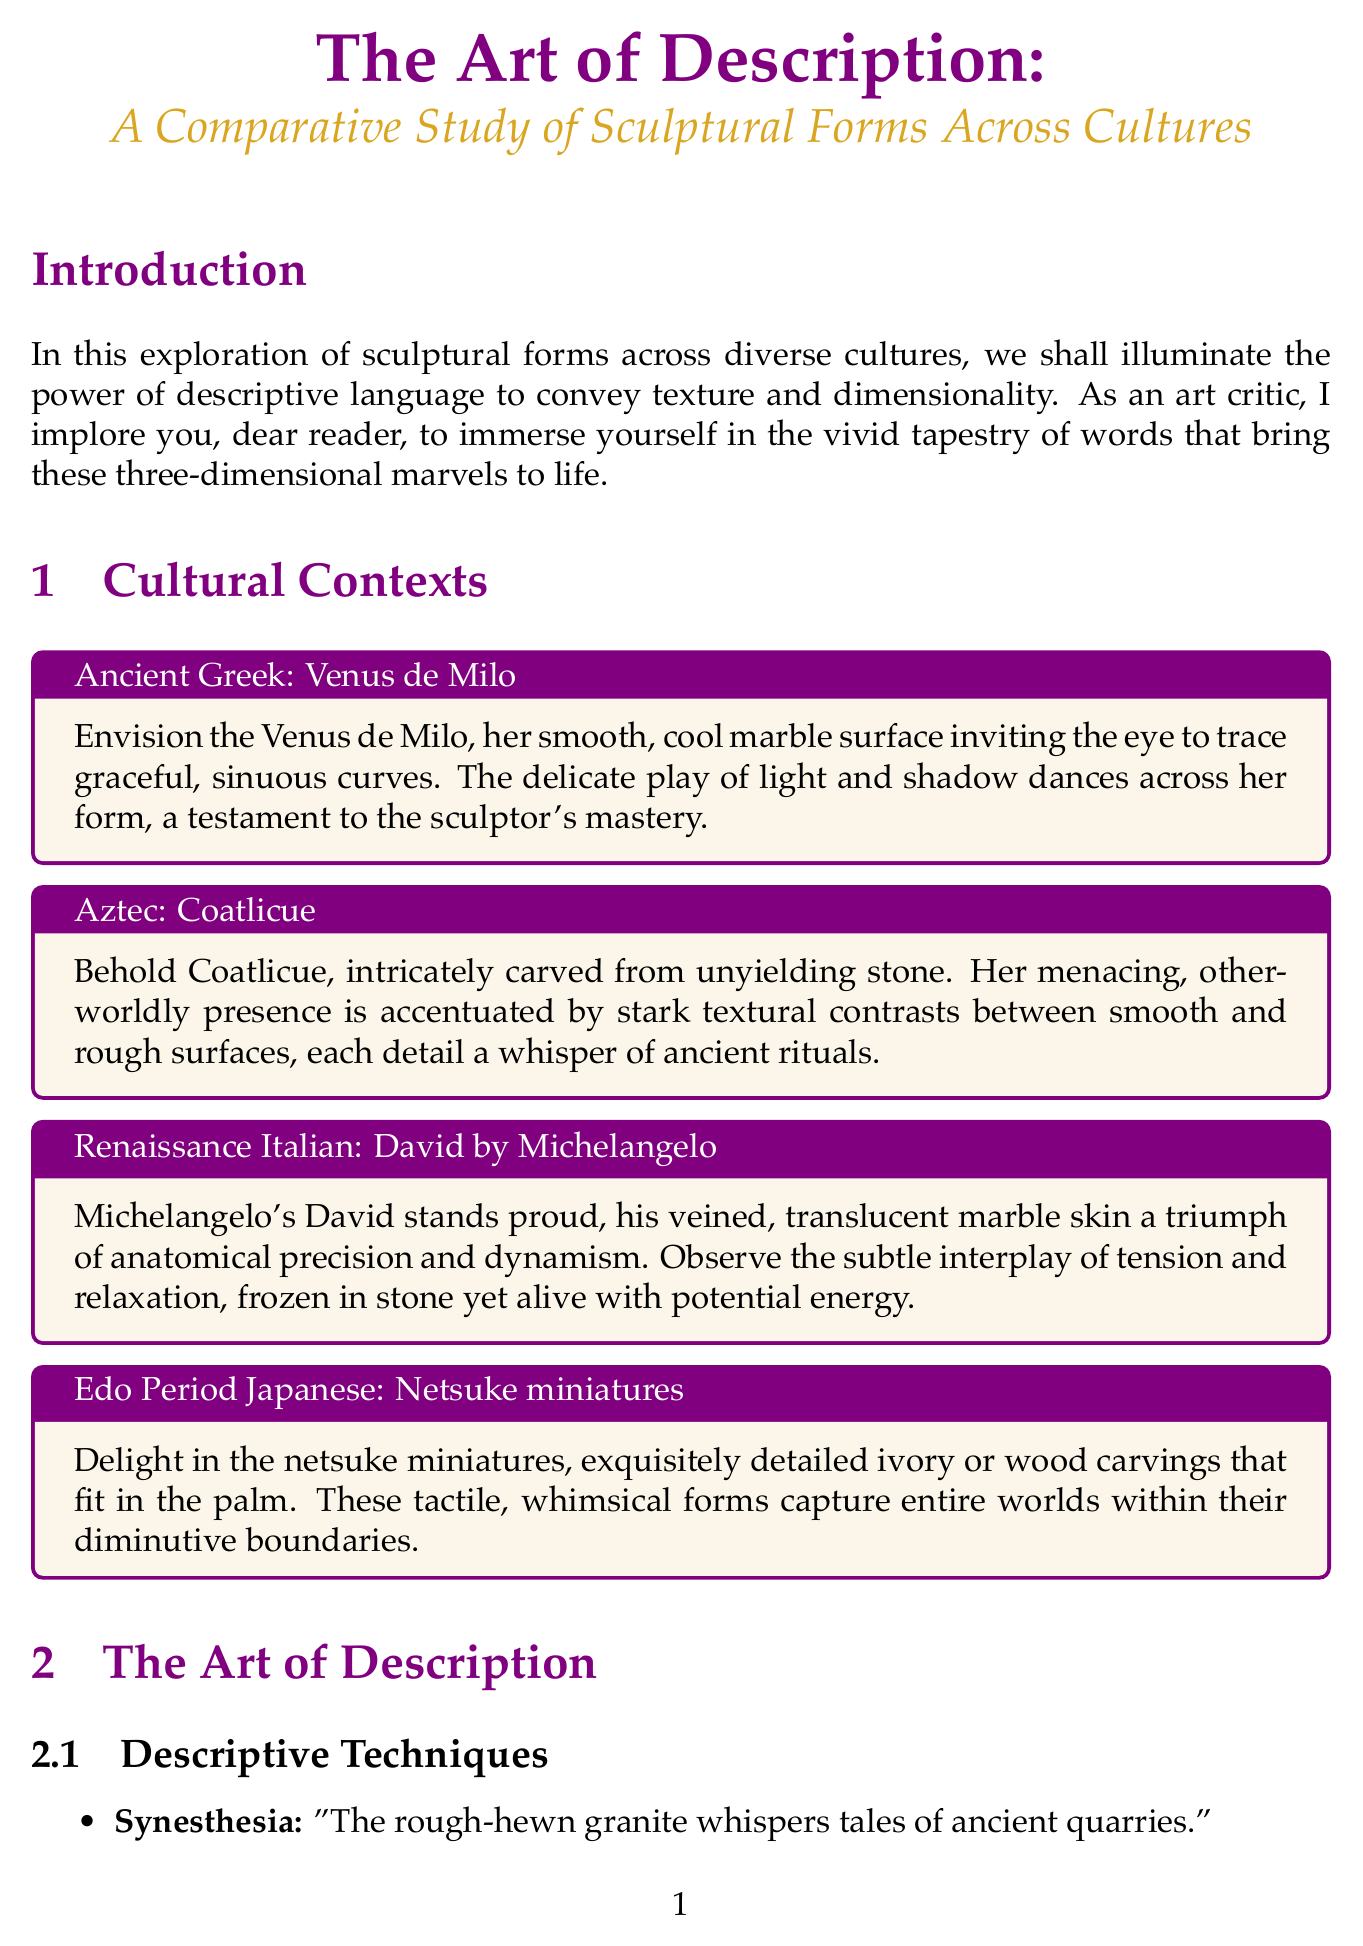What is the main theme of the report? The main theme is the comparative study of sculptural forms across cultures.
Answer: comparative study of sculptural forms across cultures Which culture is associated with the iconic work "Venus de Milo"? The "Venus de Milo" is associated with Ancient Greek culture.
Answer: Ancient Greek What technique uses the phrase "The rough-hewn granite whispers tales of ancient quarries"? This technique is called Synesthesia.
Answer: Synesthesia What is one of the key points mentioned in the conclusion? One key point is the importance of cultural context in interpreting sculptural forms.
Answer: importance of cultural context in interpreting sculptural forms Name one artist featured in the case studies. One artist featured is Auguste Rodin.
Answer: Auguste Rodin What is the texture category that describes a surface that feels smooth? The appropriate texture category is Smooth.
Answer: Smooth How does the report suggest describing the viewer's physical relationship to a sculpture? The report suggests using architectural terminology.
Answer: using architectural terminology What is the call to action for readers in the conclusion? The call to action is to describe a sculpture using all five senses.
Answer: describe a sculpture using all five senses 